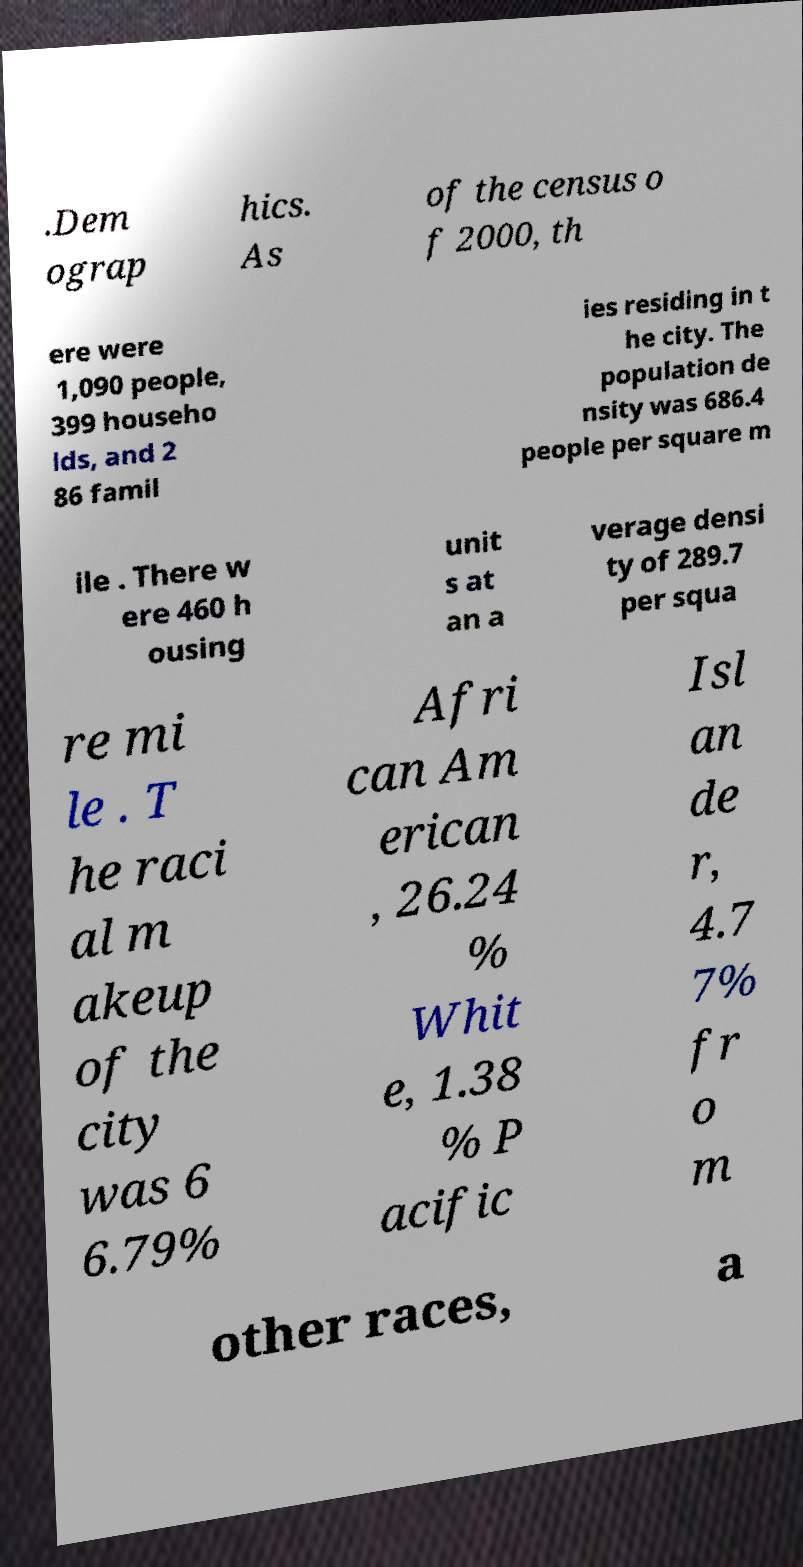Please read and relay the text visible in this image. What does it say? .Dem ograp hics. As of the census o f 2000, th ere were 1,090 people, 399 househo lds, and 2 86 famil ies residing in t he city. The population de nsity was 686.4 people per square m ile . There w ere 460 h ousing unit s at an a verage densi ty of 289.7 per squa re mi le . T he raci al m akeup of the city was 6 6.79% Afri can Am erican , 26.24 % Whit e, 1.38 % P acific Isl an de r, 4.7 7% fr o m other races, a 